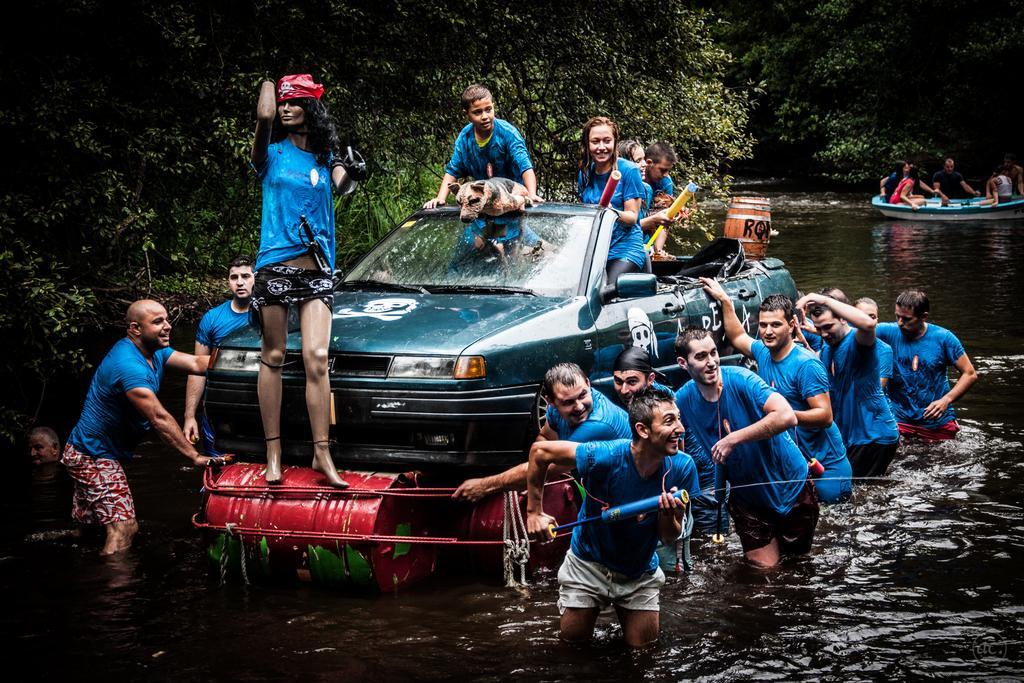Please provide a concise description of this image. In this picture we can see water and on water we have car where on car some persons, dog are standing and some other persons pushing the car and in the background we can see boat and on boat there are some persons here we have tree. 